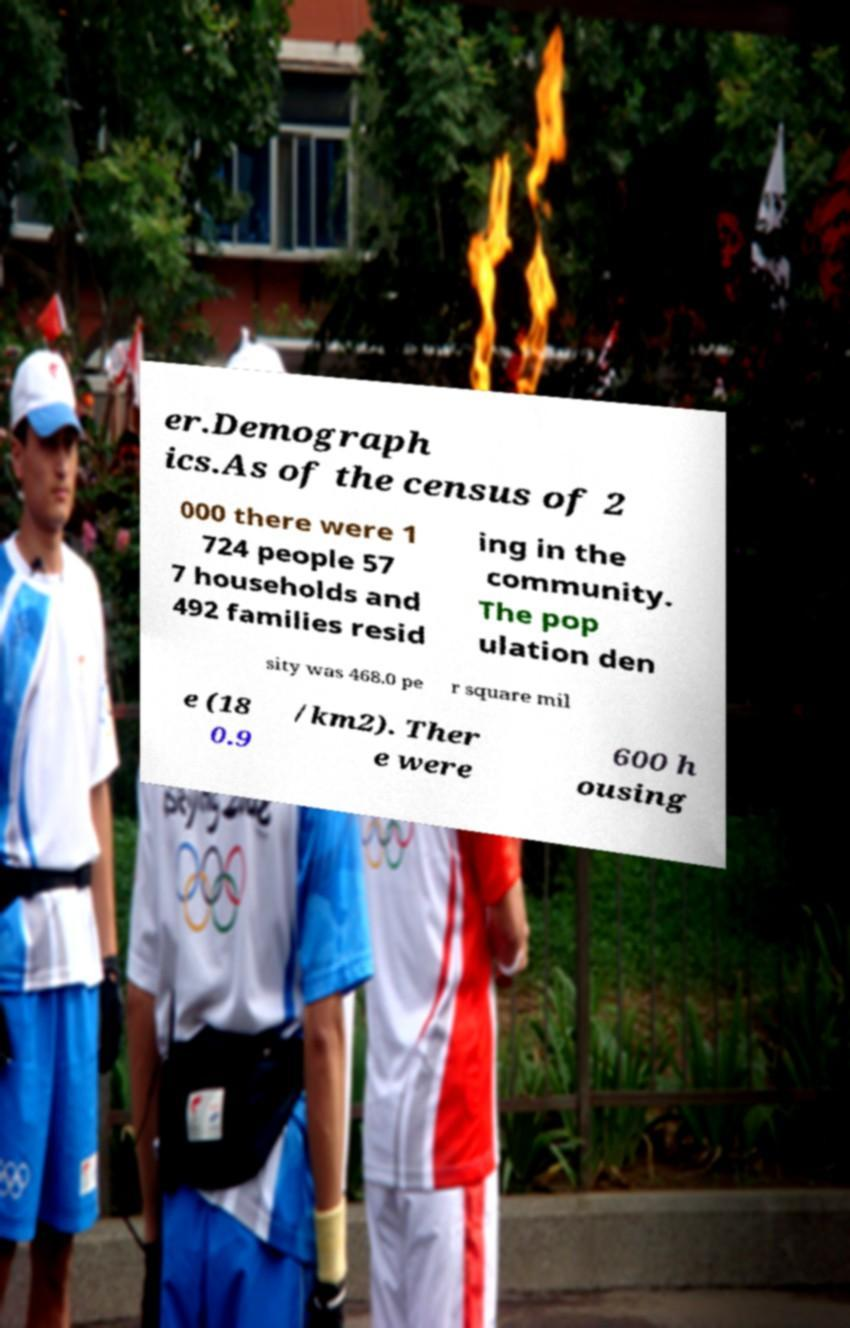Could you assist in decoding the text presented in this image and type it out clearly? er.Demograph ics.As of the census of 2 000 there were 1 724 people 57 7 households and 492 families resid ing in the community. The pop ulation den sity was 468.0 pe r square mil e (18 0.9 /km2). Ther e were 600 h ousing 